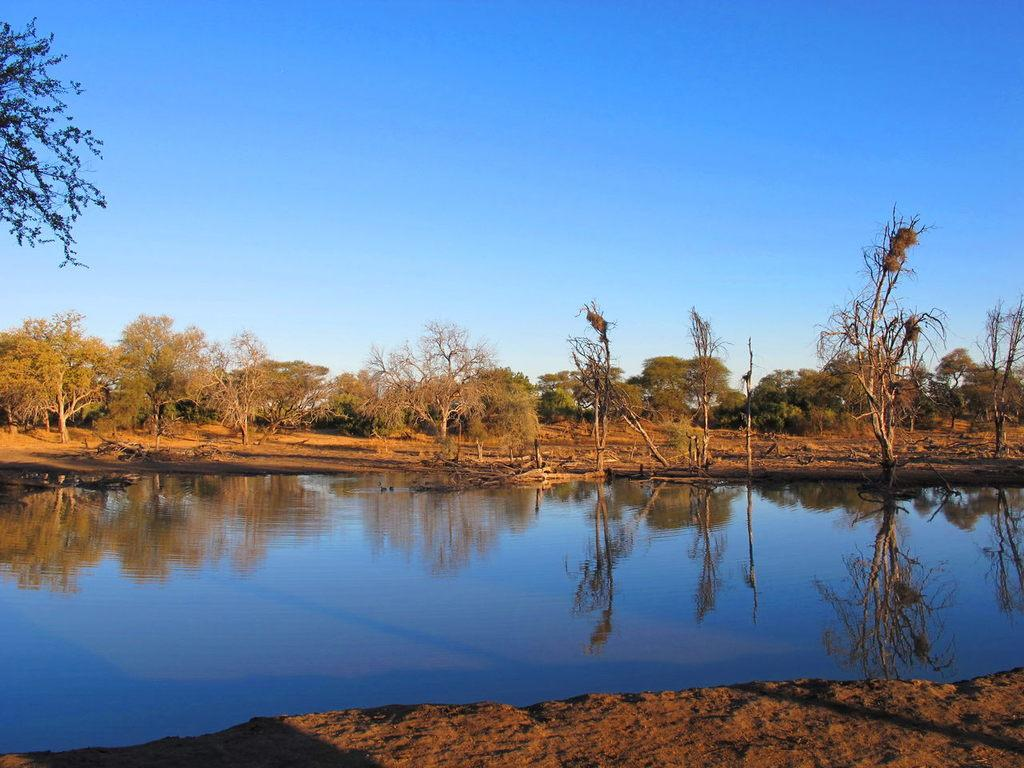What type of terrain is visible in the image? Ground and water are visible in the image. What natural elements can be seen in the image? Trees are visible in the image. What is the reflection of in the water? The reflection of the sky and trees can be seen on the surface of the water. What is visible in the background of the image? The sky is visible in the background of the image. What type of rhythm can be heard in the image? There is no sound or rhythm present in the image, as it is a still picture. 